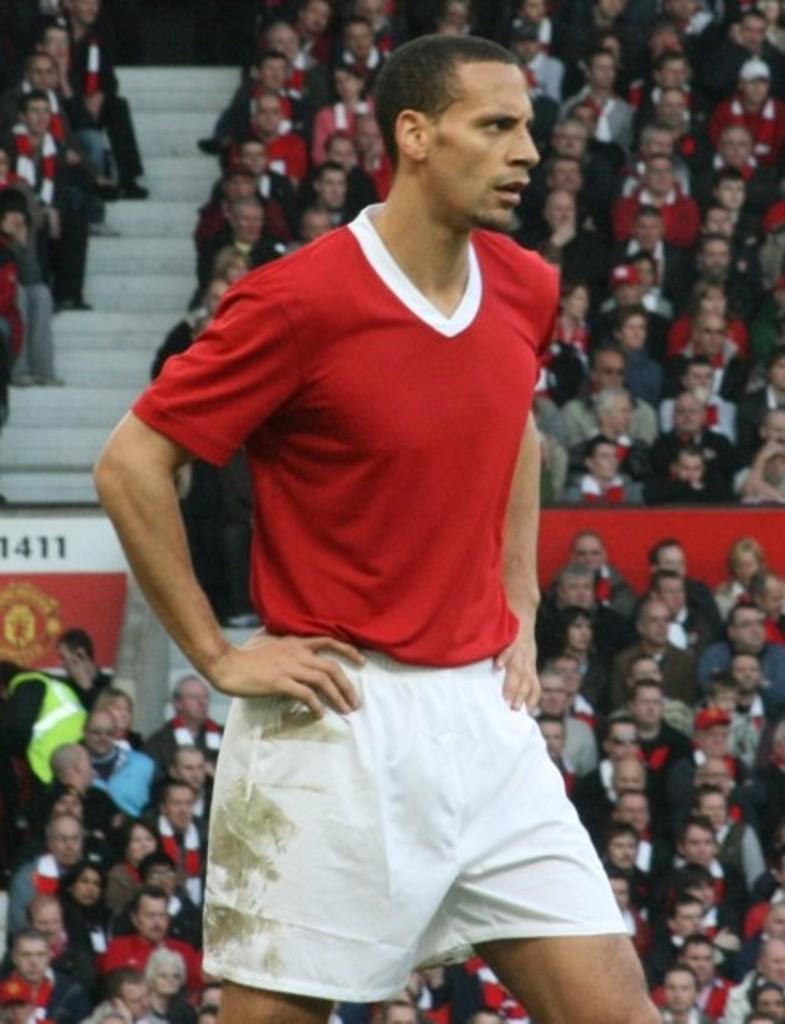What is the person in the image wearing? The person is wearing a red t-shirt and white shorts. How many people can be seen in the image? There is one person standing in the image, and many people are sitting in the background. What type of cloth is covering the dinosaurs in the image? There are no dinosaurs present in the image, so there is no cloth covering them. 